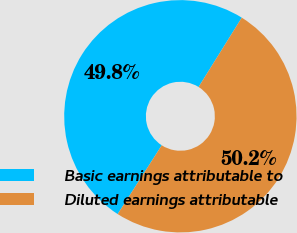Convert chart to OTSL. <chart><loc_0><loc_0><loc_500><loc_500><pie_chart><fcel>Basic earnings attributable to<fcel>Diluted earnings attributable<nl><fcel>49.8%<fcel>50.2%<nl></chart> 